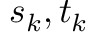Convert formula to latex. <formula><loc_0><loc_0><loc_500><loc_500>s _ { k } , t _ { k }</formula> 